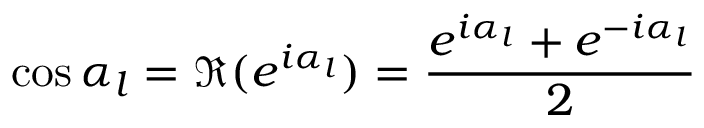<formula> <loc_0><loc_0><loc_500><loc_500>\cos \alpha _ { l } = \Re ( e ^ { i \alpha _ { l } } ) = \frac { e ^ { i \alpha _ { l } } + e ^ { - i \alpha _ { l } } } { 2 }</formula> 